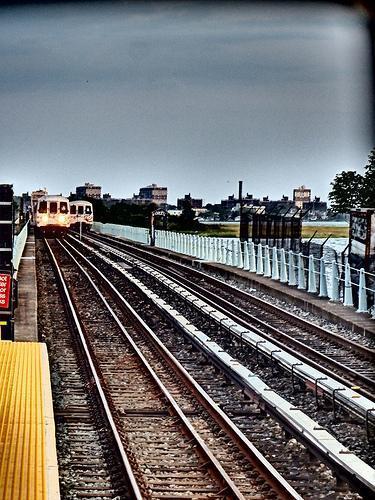How many trains are shown?
Give a very brief answer. 2. How many fences are shown?
Give a very brief answer. 1. 